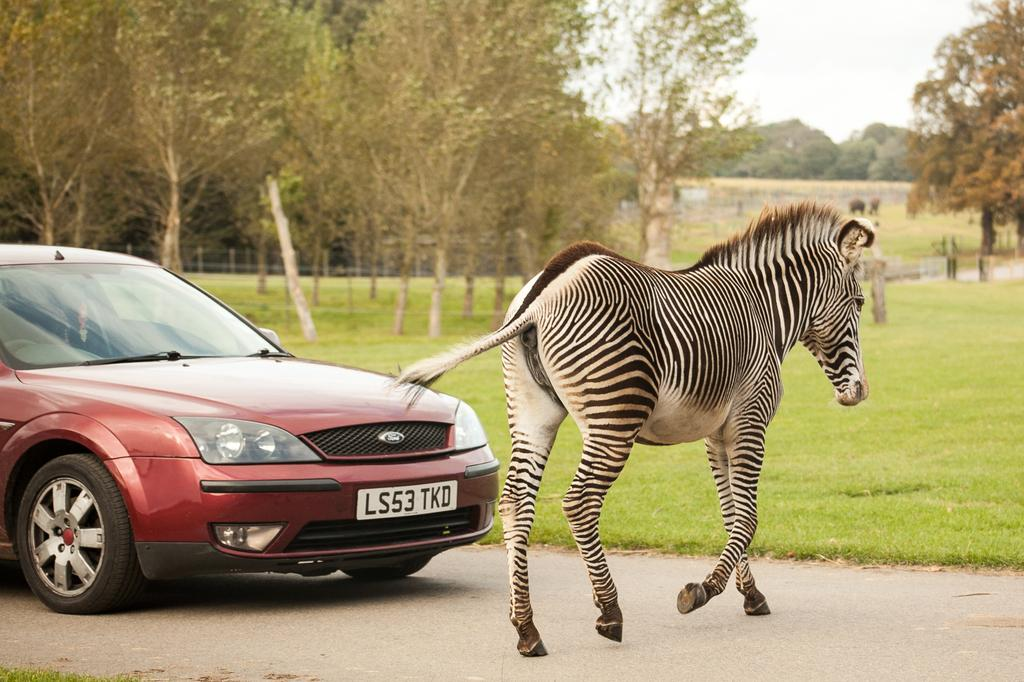What is the main subject of the image? The main subject of the image is a car on the road. What is blocking the car's path in the image? There is a giraffe in front of the car. What type of vegetation is visible beside the car? There is grass beside the car. What can be seen in the background of the image? There are trees in the background of the image. How many cakes are being served to the dogs in the image? There are no cakes or dogs present in the image. What type of hose is being used to water the trees in the image? There is no hose visible in the image; only a car, a giraffe, grass, and trees are present. 